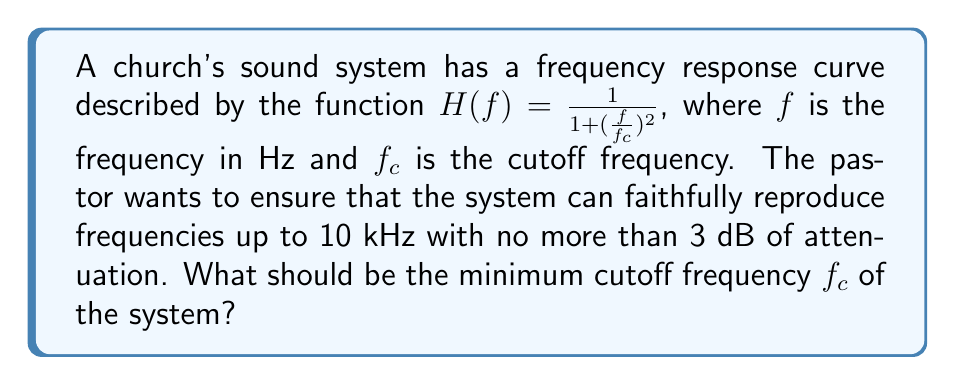Provide a solution to this math problem. To solve this problem, we need to follow these steps:

1) The frequency response is given in terms of power. We need to convert the 3 dB attenuation to a power ratio.

   3 dB = 10 log₁₀(P₁/P₂)
   0.3 = log₁₀(P₁/P₂)
   10^0.3 ≈ 2 = P₁/P₂

   So, 3 dB attenuation corresponds to half power.

2) At half power, H(f) = 0.5. We can use this to set up an equation:

   $$0.5 = \frac{1}{1 + (\frac{f}{f_c})^2}$$

3) We know f = 10 kHz (the highest frequency we want to reproduce faithfully). Let's substitute this:

   $$0.5 = \frac{1}{1 + (\frac{10000}{f_c})^2}$$

4) Now, let's solve for $f_c$:

   $$2 = 1 + (\frac{10000}{f_c})^2$$
   $$1 = (\frac{10000}{f_c})^2$$
   $$f_c = 10000$$

5) Therefore, the cutoff frequency should be at least 10 kHz.
Answer: The minimum cutoff frequency $f_c$ should be 10 kHz. 